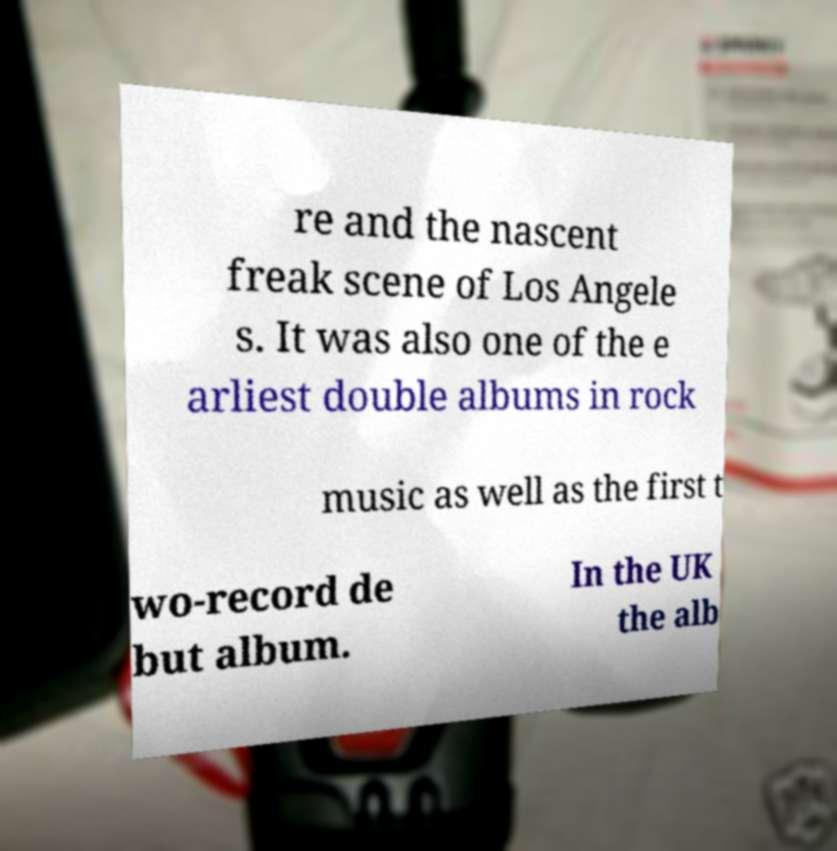What messages or text are displayed in this image? I need them in a readable, typed format. re and the nascent freak scene of Los Angele s. It was also one of the e arliest double albums in rock music as well as the first t wo-record de but album. In the UK the alb 